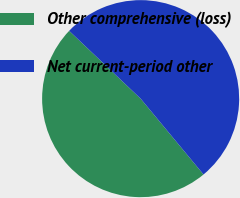Convert chart. <chart><loc_0><loc_0><loc_500><loc_500><pie_chart><fcel>Other comprehensive (loss)<fcel>Net current-period other<nl><fcel>48.1%<fcel>51.9%<nl></chart> 